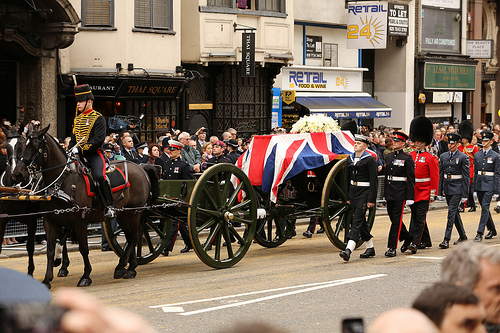The sign is where? The sign is located at a restaurant. 